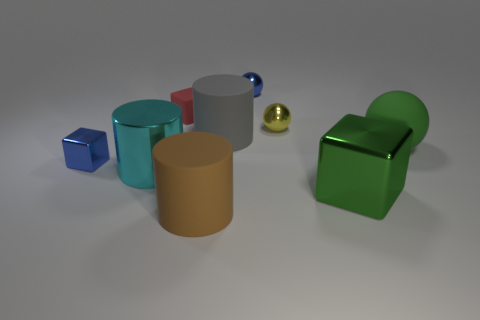There is a rubber object that is on the right side of the small blue metal ball; is it the same color as the large metallic cube?
Provide a succinct answer. Yes. Are there any metallic blocks that have the same color as the big matte sphere?
Offer a terse response. Yes. Is the matte sphere the same color as the big shiny cube?
Provide a short and direct response. Yes. What material is the big cube that is the same color as the big ball?
Offer a very short reply. Metal. How big is the matte sphere?
Make the answer very short. Large. What shape is the metallic thing that is both to the right of the matte block and in front of the matte sphere?
Make the answer very short. Cube. How many green objects are either metallic balls or large balls?
Provide a short and direct response. 1. There is a blue object on the left side of the tiny blue metallic ball; does it have the same size as the blue metal thing behind the rubber block?
Offer a very short reply. Yes. What number of objects are big brown cubes or blue shiny things?
Provide a short and direct response. 2. Are there any small gray rubber objects that have the same shape as the yellow object?
Your response must be concise. No. 